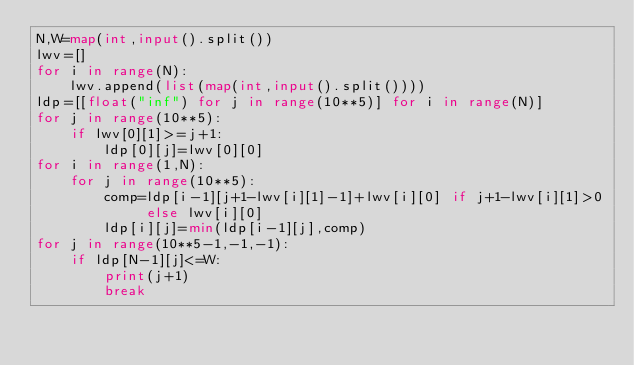Convert code to text. <code><loc_0><loc_0><loc_500><loc_500><_Python_>N,W=map(int,input().split())
lwv=[]
for i in range(N):
    lwv.append(list(map(int,input().split())))
ldp=[[float("inf") for j in range(10**5)] for i in range(N)]
for j in range(10**5):
    if lwv[0][1]>=j+1:
        ldp[0][j]=lwv[0][0]
for i in range(1,N):
    for j in range(10**5):
        comp=ldp[i-1][j+1-lwv[i][1]-1]+lwv[i][0] if j+1-lwv[i][1]>0 else lwv[i][0]
        ldp[i][j]=min(ldp[i-1][j],comp)
for j in range(10**5-1,-1,-1):
    if ldp[N-1][j]<=W:
        print(j+1)
        break
</code> 